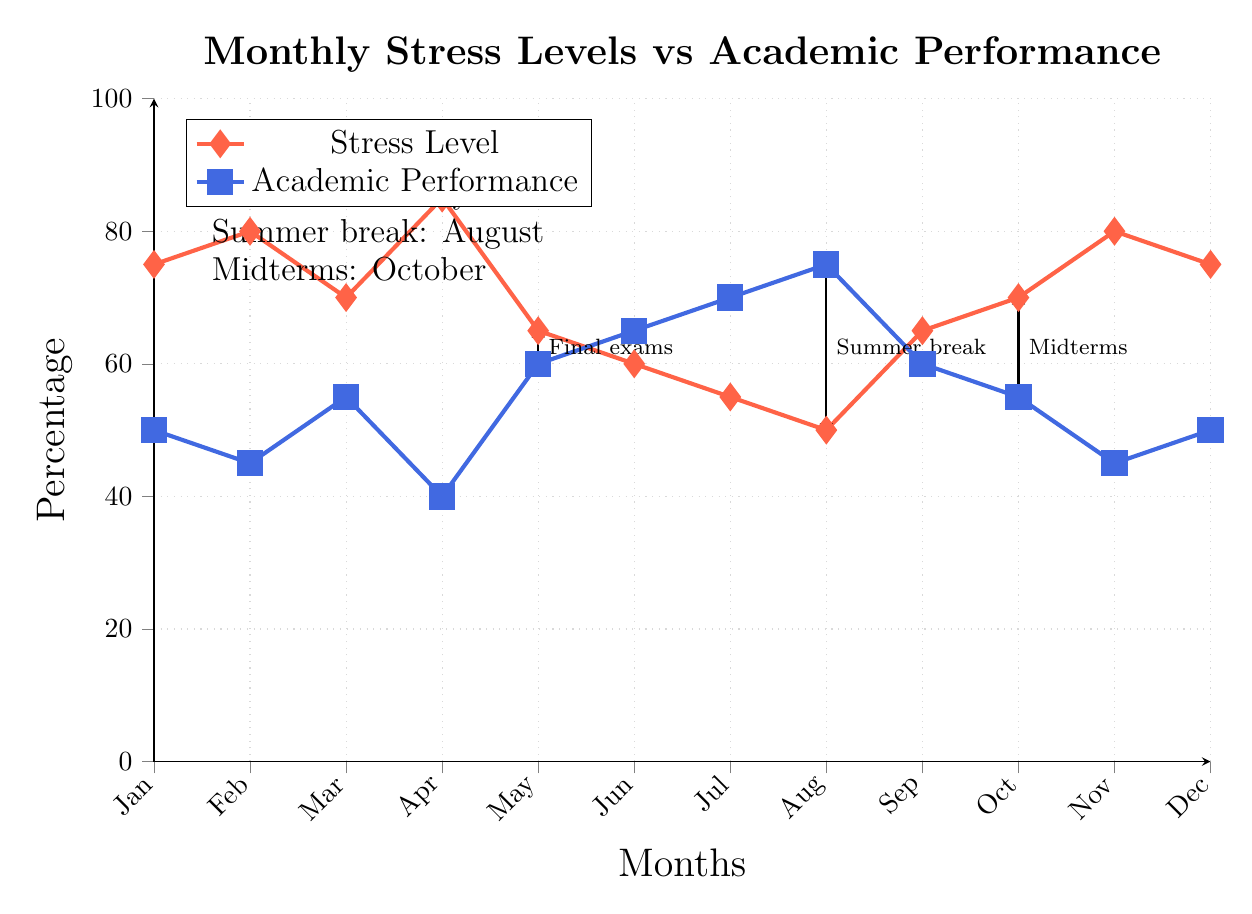What's the stress level in July? From the diagram, we read the stress level for July, which is marked as month 6 (0-indexed). Looking at the stress level line, it indicates a value of 50.
Answer: 50 What is the academic performance percentage for February? To find the academic performance percentage for February, we look at month 1 (0-indexed) on the performance line. It shows a percentage of 45.
Answer: 45 Which month corresponds to the highest stress level? By examining the stress line for all months, we identify the peak at month 3 (April) with a stress level of 85.
Answer: April How do stress levels in August compare to academic performance in that month? In August (month 7), the stress level is at 50, while the academic performance is at 75. The comparison indicates stress levels are lower than academic performance.
Answer: Lower What is the trend in stress levels from January to December? Observing the stress line across the months, we note the trend shows a peak at April, followed by a decline towards August, and a slight rise again towards December.
Answer: Fluctuating What notable events are indicated on the graph? The annotations mention three significant events: Final exams in May, Summer break in August, and Midterms in October, which may impact stress levels and academic performance.
Answer: Exams and breaks In which month does academic performance drop the most compared to the previous month? By analyzing the performance data, we see a drop from September (60) to October (45), which is the largest decrease of 15.
Answer: October What is the average stress level from January through June? To compute the average stress level for these months, we add the values for January (75), February (80), March (70), April (85), May (65), June (60), then divide by 6. This gives (75+80+70+85+65+60)/6 = 70.
Answer: 70 What percentage of months show an increase in academic performance? Examining the performance line month by month, we find that performance increased from January (50) to February (45) and two other instances, totaling three increases within 12 months, resulting in 25% of the months showing improvement.
Answer: 25% 